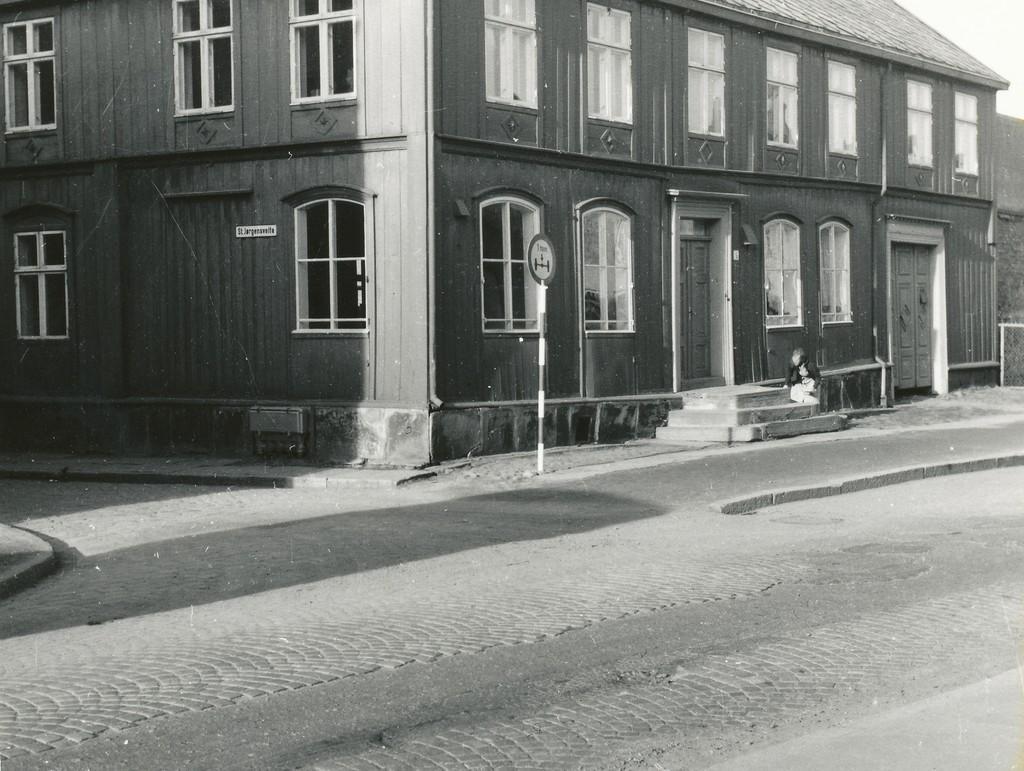In one or two sentences, can you explain what this image depicts? In this picture I can see there is a building and it has few windows and doors and there are stairs and there is a road here. The sky is clear. 